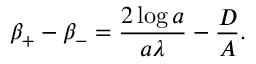<formula> <loc_0><loc_0><loc_500><loc_500>\beta _ { + } - \beta _ { - } = \frac { 2 \log a } { a \lambda } - \frac { D } { A } .</formula> 